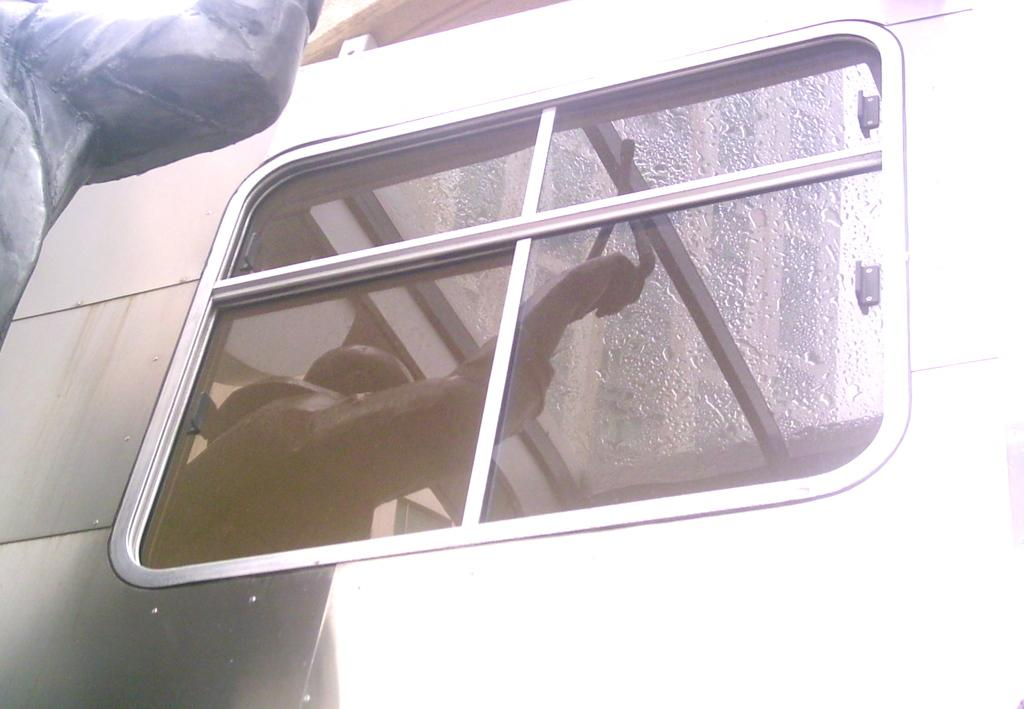What is present in the image that allows us to see outside? There is a window in the image. Can you describe the reflection visible on the window? The window has a reflection of a person. What material is the window made of? The window is made of glass. What type of picture is the person cooking in the image? There is no picture or person cooking present in the image; it only features a window with a reflection of a person. 